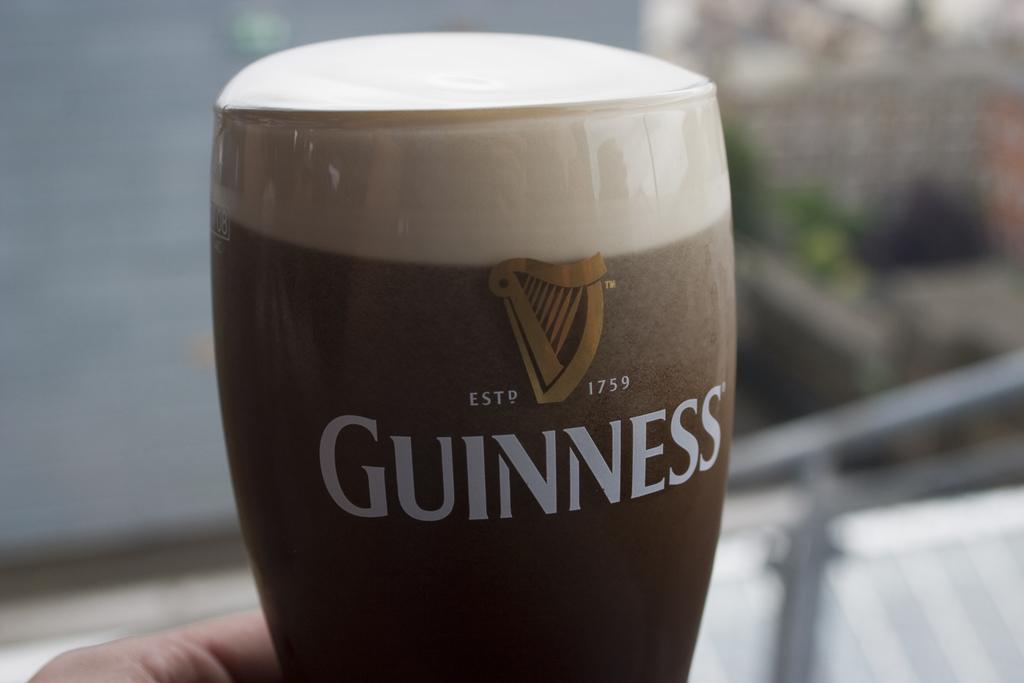What year was guinness established?
Offer a terse response. 1759. What is the name of the beer?
Make the answer very short. Guinness. 